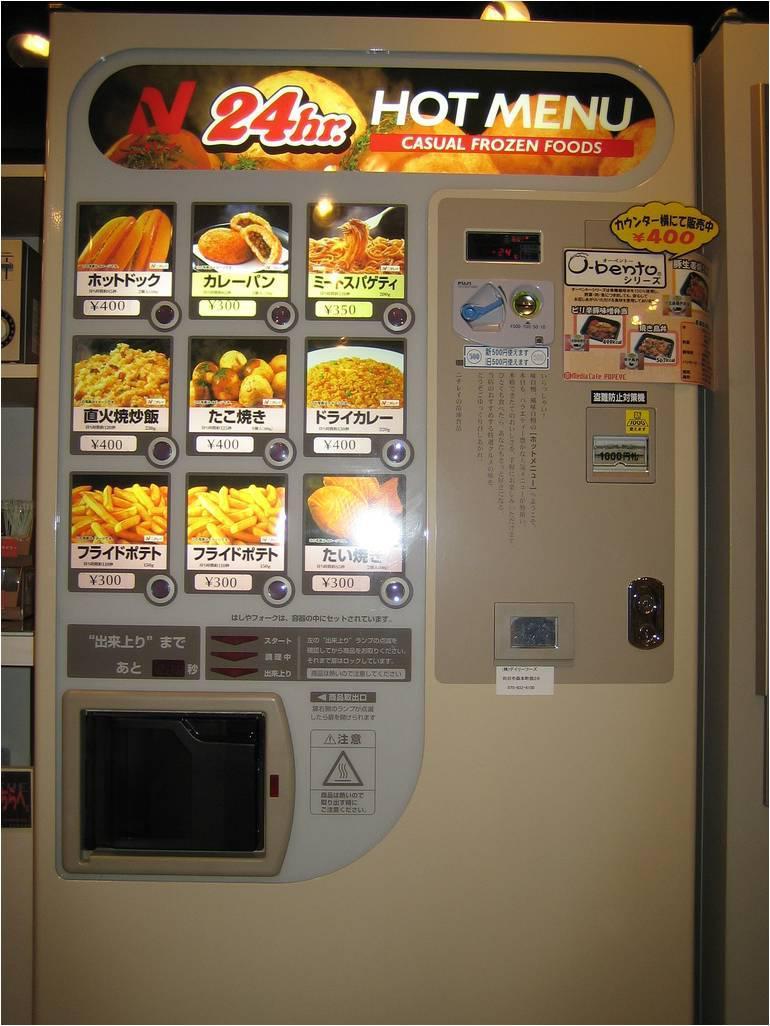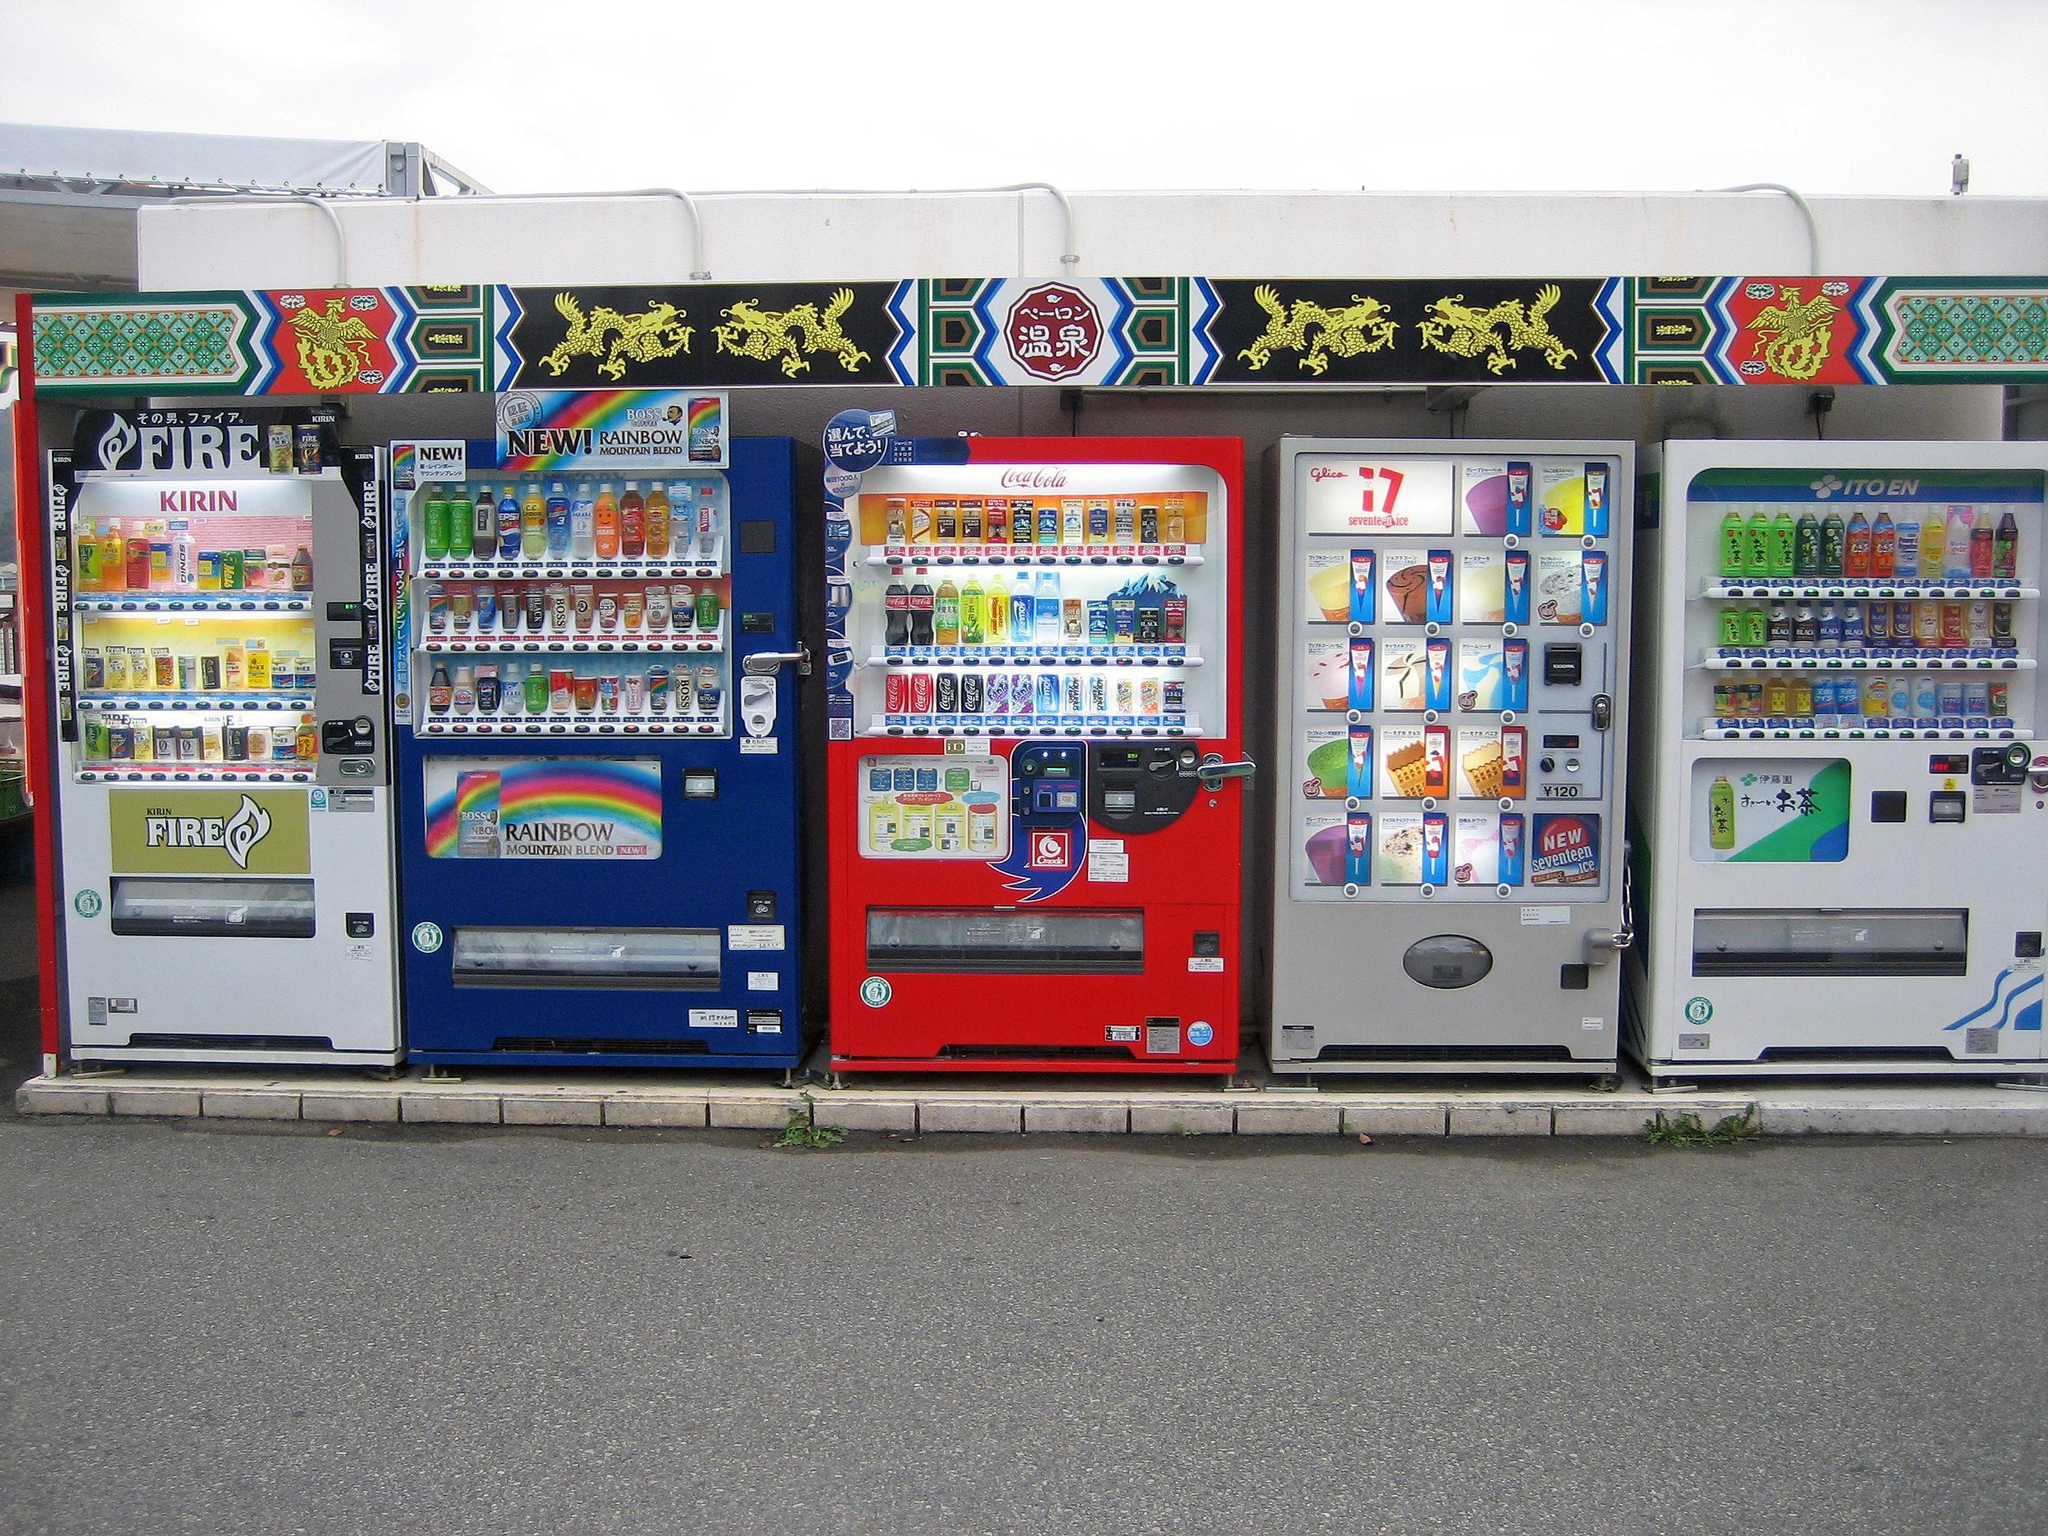The first image is the image on the left, the second image is the image on the right. Assess this claim about the two images: "The right image shows a row of at least four vending machines.". Correct or not? Answer yes or no. Yes. 